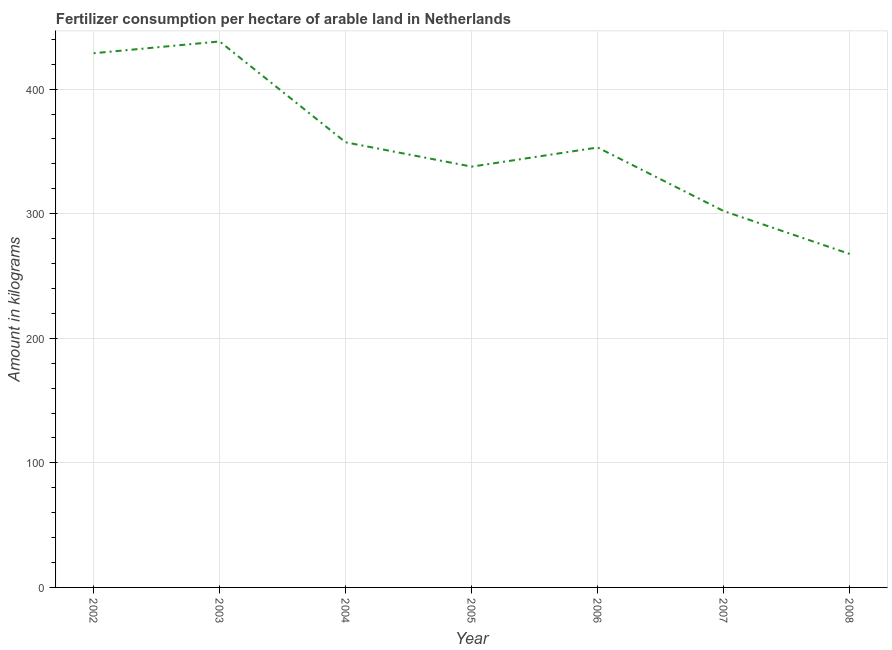What is the amount of fertilizer consumption in 2003?
Ensure brevity in your answer.  438.29. Across all years, what is the maximum amount of fertilizer consumption?
Your response must be concise. 438.29. Across all years, what is the minimum amount of fertilizer consumption?
Offer a terse response. 267.71. What is the sum of the amount of fertilizer consumption?
Make the answer very short. 2485.23. What is the difference between the amount of fertilizer consumption in 2003 and 2006?
Give a very brief answer. 85.15. What is the average amount of fertilizer consumption per year?
Offer a very short reply. 355.03. What is the median amount of fertilizer consumption?
Give a very brief answer. 353.15. In how many years, is the amount of fertilizer consumption greater than 260 kg?
Your answer should be very brief. 7. Do a majority of the years between 2006 and 2002 (inclusive) have amount of fertilizer consumption greater than 40 kg?
Your answer should be very brief. Yes. What is the ratio of the amount of fertilizer consumption in 2003 to that in 2008?
Your response must be concise. 1.64. Is the difference between the amount of fertilizer consumption in 2002 and 2003 greater than the difference between any two years?
Keep it short and to the point. No. What is the difference between the highest and the second highest amount of fertilizer consumption?
Make the answer very short. 9.47. What is the difference between the highest and the lowest amount of fertilizer consumption?
Your answer should be very brief. 170.58. Does the amount of fertilizer consumption monotonically increase over the years?
Ensure brevity in your answer.  No. How many lines are there?
Give a very brief answer. 1. How many years are there in the graph?
Give a very brief answer. 7. What is the difference between two consecutive major ticks on the Y-axis?
Offer a terse response. 100. Are the values on the major ticks of Y-axis written in scientific E-notation?
Your response must be concise. No. Does the graph contain any zero values?
Make the answer very short. No. Does the graph contain grids?
Offer a terse response. Yes. What is the title of the graph?
Give a very brief answer. Fertilizer consumption per hectare of arable land in Netherlands . What is the label or title of the X-axis?
Give a very brief answer. Year. What is the label or title of the Y-axis?
Provide a succinct answer. Amount in kilograms. What is the Amount in kilograms in 2002?
Offer a very short reply. 428.82. What is the Amount in kilograms of 2003?
Your answer should be compact. 438.29. What is the Amount in kilograms of 2004?
Keep it short and to the point. 357.31. What is the Amount in kilograms in 2005?
Give a very brief answer. 337.81. What is the Amount in kilograms of 2006?
Offer a very short reply. 353.15. What is the Amount in kilograms of 2007?
Offer a terse response. 302.14. What is the Amount in kilograms in 2008?
Your answer should be compact. 267.71. What is the difference between the Amount in kilograms in 2002 and 2003?
Your answer should be compact. -9.47. What is the difference between the Amount in kilograms in 2002 and 2004?
Your response must be concise. 71.51. What is the difference between the Amount in kilograms in 2002 and 2005?
Your answer should be very brief. 91.02. What is the difference between the Amount in kilograms in 2002 and 2006?
Your answer should be very brief. 75.68. What is the difference between the Amount in kilograms in 2002 and 2007?
Offer a very short reply. 126.68. What is the difference between the Amount in kilograms in 2002 and 2008?
Offer a terse response. 161.11. What is the difference between the Amount in kilograms in 2003 and 2004?
Provide a short and direct response. 80.98. What is the difference between the Amount in kilograms in 2003 and 2005?
Your answer should be compact. 100.48. What is the difference between the Amount in kilograms in 2003 and 2006?
Ensure brevity in your answer.  85.15. What is the difference between the Amount in kilograms in 2003 and 2007?
Provide a short and direct response. 136.15. What is the difference between the Amount in kilograms in 2003 and 2008?
Provide a succinct answer. 170.58. What is the difference between the Amount in kilograms in 2004 and 2005?
Ensure brevity in your answer.  19.51. What is the difference between the Amount in kilograms in 2004 and 2006?
Your response must be concise. 4.17. What is the difference between the Amount in kilograms in 2004 and 2007?
Offer a terse response. 55.17. What is the difference between the Amount in kilograms in 2004 and 2008?
Make the answer very short. 89.6. What is the difference between the Amount in kilograms in 2005 and 2006?
Keep it short and to the point. -15.34. What is the difference between the Amount in kilograms in 2005 and 2007?
Offer a terse response. 35.67. What is the difference between the Amount in kilograms in 2005 and 2008?
Provide a succinct answer. 70.1. What is the difference between the Amount in kilograms in 2006 and 2007?
Offer a terse response. 51.01. What is the difference between the Amount in kilograms in 2006 and 2008?
Ensure brevity in your answer.  85.44. What is the difference between the Amount in kilograms in 2007 and 2008?
Provide a succinct answer. 34.43. What is the ratio of the Amount in kilograms in 2002 to that in 2004?
Provide a short and direct response. 1.2. What is the ratio of the Amount in kilograms in 2002 to that in 2005?
Make the answer very short. 1.27. What is the ratio of the Amount in kilograms in 2002 to that in 2006?
Your answer should be very brief. 1.21. What is the ratio of the Amount in kilograms in 2002 to that in 2007?
Offer a terse response. 1.42. What is the ratio of the Amount in kilograms in 2002 to that in 2008?
Your answer should be compact. 1.6. What is the ratio of the Amount in kilograms in 2003 to that in 2004?
Offer a terse response. 1.23. What is the ratio of the Amount in kilograms in 2003 to that in 2005?
Provide a succinct answer. 1.3. What is the ratio of the Amount in kilograms in 2003 to that in 2006?
Keep it short and to the point. 1.24. What is the ratio of the Amount in kilograms in 2003 to that in 2007?
Offer a terse response. 1.45. What is the ratio of the Amount in kilograms in 2003 to that in 2008?
Provide a succinct answer. 1.64. What is the ratio of the Amount in kilograms in 2004 to that in 2005?
Give a very brief answer. 1.06. What is the ratio of the Amount in kilograms in 2004 to that in 2006?
Offer a very short reply. 1.01. What is the ratio of the Amount in kilograms in 2004 to that in 2007?
Offer a terse response. 1.18. What is the ratio of the Amount in kilograms in 2004 to that in 2008?
Provide a short and direct response. 1.33. What is the ratio of the Amount in kilograms in 2005 to that in 2006?
Give a very brief answer. 0.96. What is the ratio of the Amount in kilograms in 2005 to that in 2007?
Offer a very short reply. 1.12. What is the ratio of the Amount in kilograms in 2005 to that in 2008?
Offer a terse response. 1.26. What is the ratio of the Amount in kilograms in 2006 to that in 2007?
Provide a short and direct response. 1.17. What is the ratio of the Amount in kilograms in 2006 to that in 2008?
Your response must be concise. 1.32. What is the ratio of the Amount in kilograms in 2007 to that in 2008?
Keep it short and to the point. 1.13. 